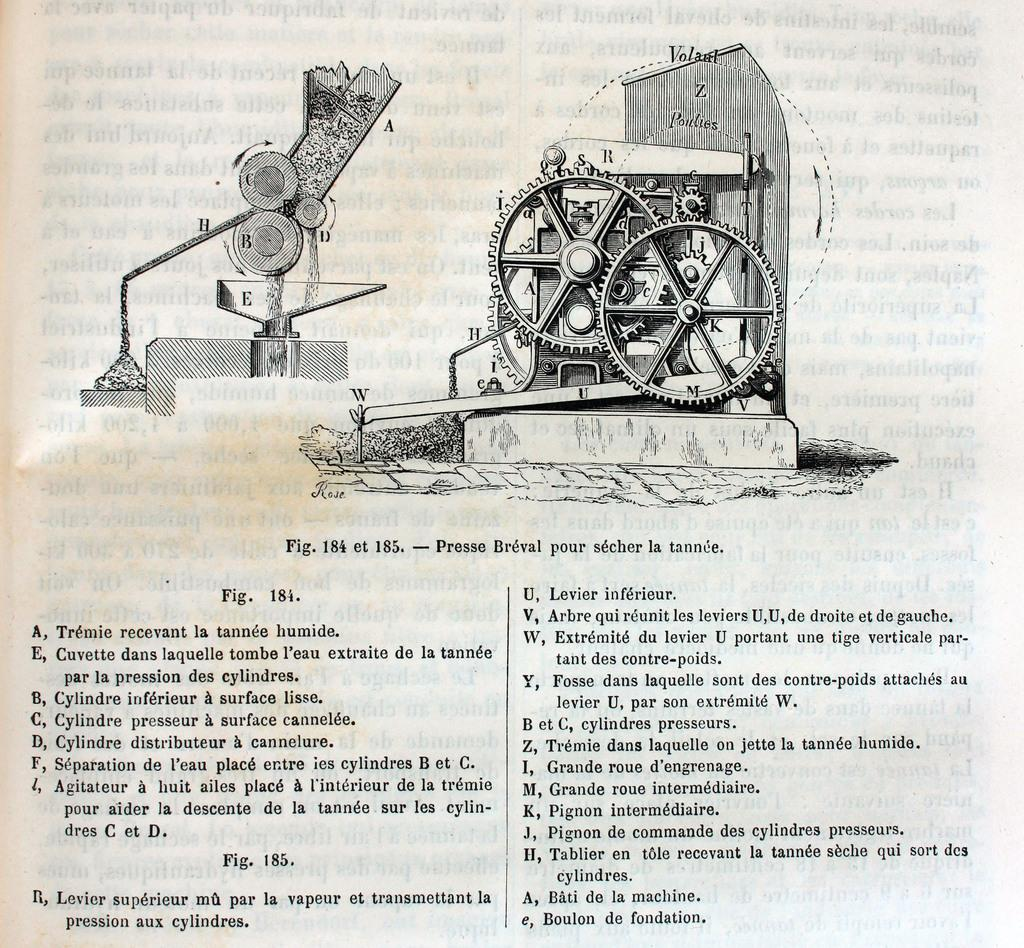What is present in the image that contains information? There is a paper in the image that contains text. What type of content is on the paper? The paper contains images that resemble a machine. What type of fuel is used by the machine depicted on the paper? There is no information about fuel in the image, as it only contains a paper with text and images resembling a machine. 